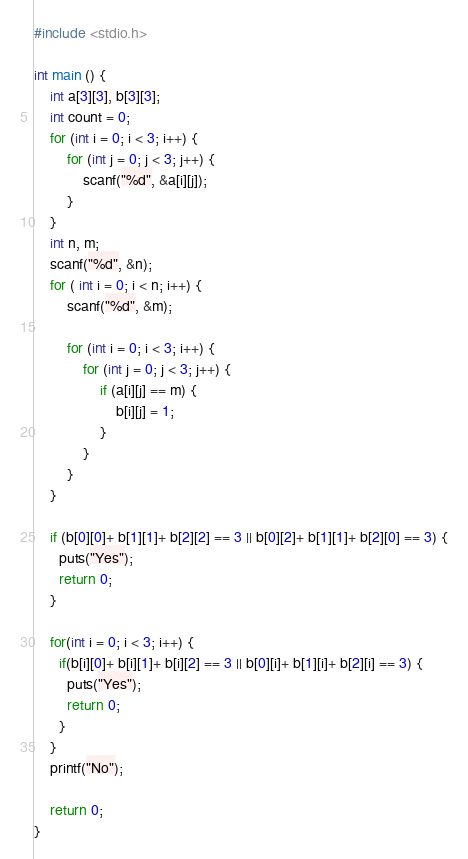<code> <loc_0><loc_0><loc_500><loc_500><_C_>#include <stdio.h>

int main () {
	int a[3][3], b[3][3];
	int count = 0;
	for (int i = 0; i < 3; i++) {
		for (int j = 0; j < 3; j++) {
			scanf("%d", &a[i][j]);
		}
	}
	int n, m;
	scanf("%d", &n);
	for ( int i = 0; i < n; i++) {
		scanf("%d", &m);
		
		for (int i = 0; i < 3; i++) {
			for (int j = 0; j < 3; j++) {
				if (a[i][j] == m) {
					b[i][j] = 1;
				}
			}
		}
	}
	
	if (b[0][0]+ b[1][1]+ b[2][2] == 3 || b[0][2]+ b[1][1]+ b[2][0] == 3) {
      puts("Yes");
      return 0;
    }
	
	for(int i = 0; i < 3; i++) {
      if(b[i][0]+ b[i][1]+ b[i][2] == 3 || b[0][i]+ b[1][i]+ b[2][i] == 3) {
        puts("Yes");
        return 0;
      }
    }
	printf("No");
	
	return 0;
}</code> 